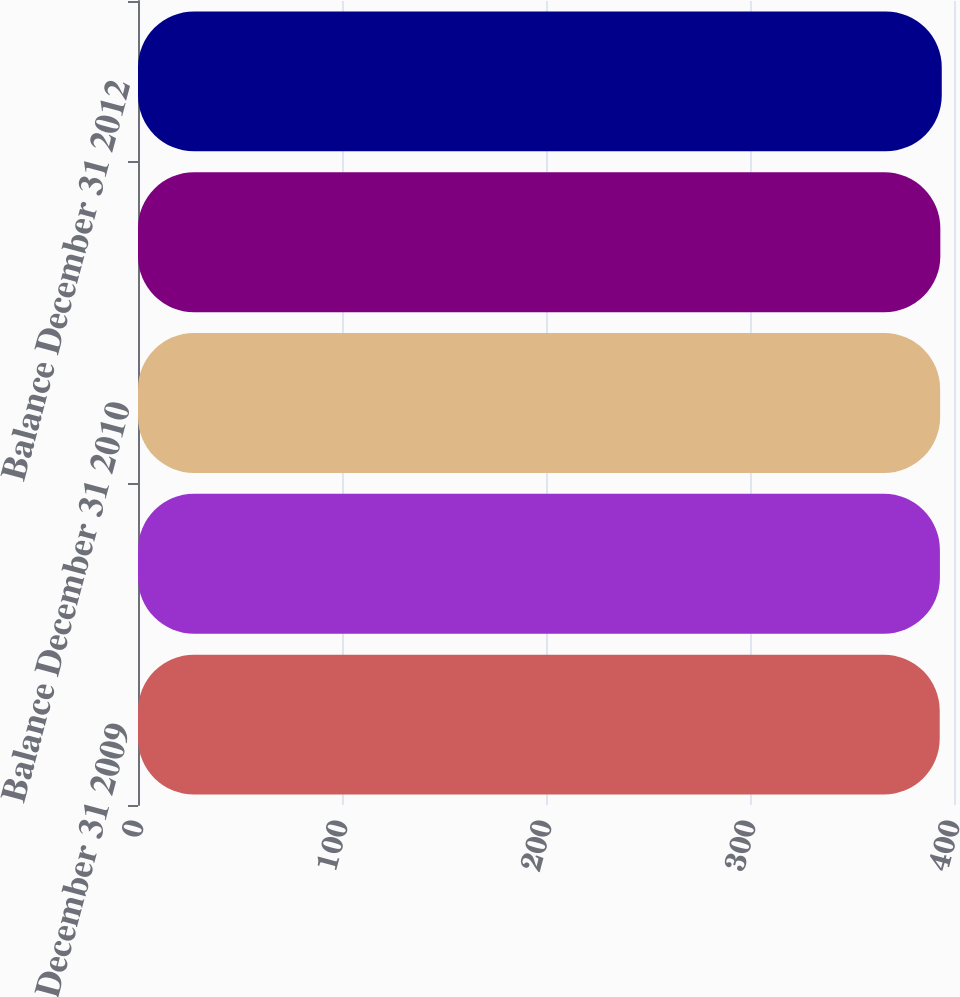Convert chart. <chart><loc_0><loc_0><loc_500><loc_500><bar_chart><fcel>Balance December 31 2009<fcel>Balance as adjusted January 1<fcel>Balance December 31 2010<fcel>Balance December 31 2011<fcel>Balance December 31 2012<nl><fcel>393<fcel>393.1<fcel>393.2<fcel>393.3<fcel>394<nl></chart> 